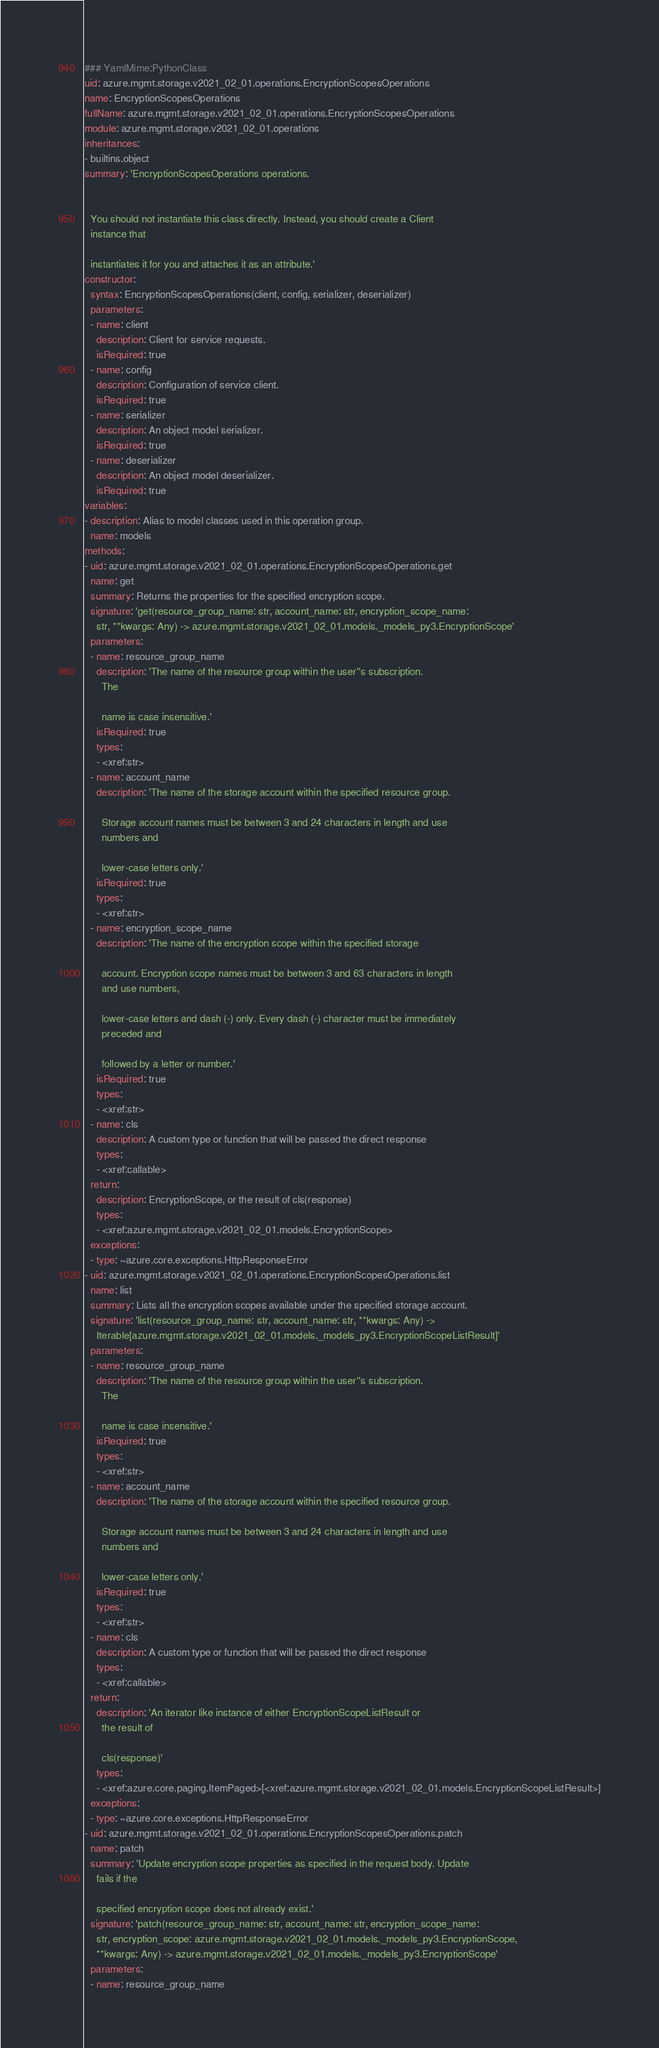Convert code to text. <code><loc_0><loc_0><loc_500><loc_500><_YAML_>### YamlMime:PythonClass
uid: azure.mgmt.storage.v2021_02_01.operations.EncryptionScopesOperations
name: EncryptionScopesOperations
fullName: azure.mgmt.storage.v2021_02_01.operations.EncryptionScopesOperations
module: azure.mgmt.storage.v2021_02_01.operations
inheritances:
- builtins.object
summary: 'EncryptionScopesOperations operations.


  You should not instantiate this class directly. Instead, you should create a Client
  instance that

  instantiates it for you and attaches it as an attribute.'
constructor:
  syntax: EncryptionScopesOperations(client, config, serializer, deserializer)
  parameters:
  - name: client
    description: Client for service requests.
    isRequired: true
  - name: config
    description: Configuration of service client.
    isRequired: true
  - name: serializer
    description: An object model serializer.
    isRequired: true
  - name: deserializer
    description: An object model deserializer.
    isRequired: true
variables:
- description: Alias to model classes used in this operation group.
  name: models
methods:
- uid: azure.mgmt.storage.v2021_02_01.operations.EncryptionScopesOperations.get
  name: get
  summary: Returns the properties for the specified encryption scope.
  signature: 'get(resource_group_name: str, account_name: str, encryption_scope_name:
    str, **kwargs: Any) -> azure.mgmt.storage.v2021_02_01.models._models_py3.EncryptionScope'
  parameters:
  - name: resource_group_name
    description: 'The name of the resource group within the user''s subscription.
      The

      name is case insensitive.'
    isRequired: true
    types:
    - <xref:str>
  - name: account_name
    description: 'The name of the storage account within the specified resource group.

      Storage account names must be between 3 and 24 characters in length and use
      numbers and

      lower-case letters only.'
    isRequired: true
    types:
    - <xref:str>
  - name: encryption_scope_name
    description: 'The name of the encryption scope within the specified storage

      account. Encryption scope names must be between 3 and 63 characters in length
      and use numbers,

      lower-case letters and dash (-) only. Every dash (-) character must be immediately
      preceded and

      followed by a letter or number.'
    isRequired: true
    types:
    - <xref:str>
  - name: cls
    description: A custom type or function that will be passed the direct response
    types:
    - <xref:callable>
  return:
    description: EncryptionScope, or the result of cls(response)
    types:
    - <xref:azure.mgmt.storage.v2021_02_01.models.EncryptionScope>
  exceptions:
  - type: ~azure.core.exceptions.HttpResponseError
- uid: azure.mgmt.storage.v2021_02_01.operations.EncryptionScopesOperations.list
  name: list
  summary: Lists all the encryption scopes available under the specified storage account.
  signature: 'list(resource_group_name: str, account_name: str, **kwargs: Any) ->
    Iterable[azure.mgmt.storage.v2021_02_01.models._models_py3.EncryptionScopeListResult]'
  parameters:
  - name: resource_group_name
    description: 'The name of the resource group within the user''s subscription.
      The

      name is case insensitive.'
    isRequired: true
    types:
    - <xref:str>
  - name: account_name
    description: 'The name of the storage account within the specified resource group.

      Storage account names must be between 3 and 24 characters in length and use
      numbers and

      lower-case letters only.'
    isRequired: true
    types:
    - <xref:str>
  - name: cls
    description: A custom type or function that will be passed the direct response
    types:
    - <xref:callable>
  return:
    description: 'An iterator like instance of either EncryptionScopeListResult or
      the result of

      cls(response)'
    types:
    - <xref:azure.core.paging.ItemPaged>[<xref:azure.mgmt.storage.v2021_02_01.models.EncryptionScopeListResult>]
  exceptions:
  - type: ~azure.core.exceptions.HttpResponseError
- uid: azure.mgmt.storage.v2021_02_01.operations.EncryptionScopesOperations.patch
  name: patch
  summary: 'Update encryption scope properties as specified in the request body. Update
    fails if the

    specified encryption scope does not already exist.'
  signature: 'patch(resource_group_name: str, account_name: str, encryption_scope_name:
    str, encryption_scope: azure.mgmt.storage.v2021_02_01.models._models_py3.EncryptionScope,
    **kwargs: Any) -> azure.mgmt.storage.v2021_02_01.models._models_py3.EncryptionScope'
  parameters:
  - name: resource_group_name</code> 